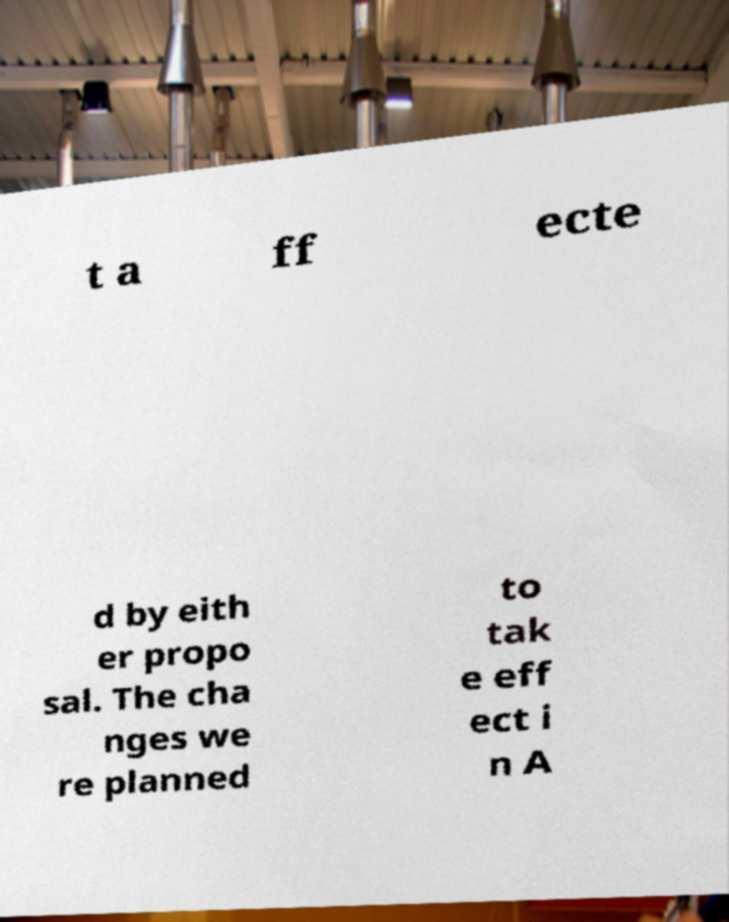What messages or text are displayed in this image? I need them in a readable, typed format. t a ff ecte d by eith er propo sal. The cha nges we re planned to tak e eff ect i n A 